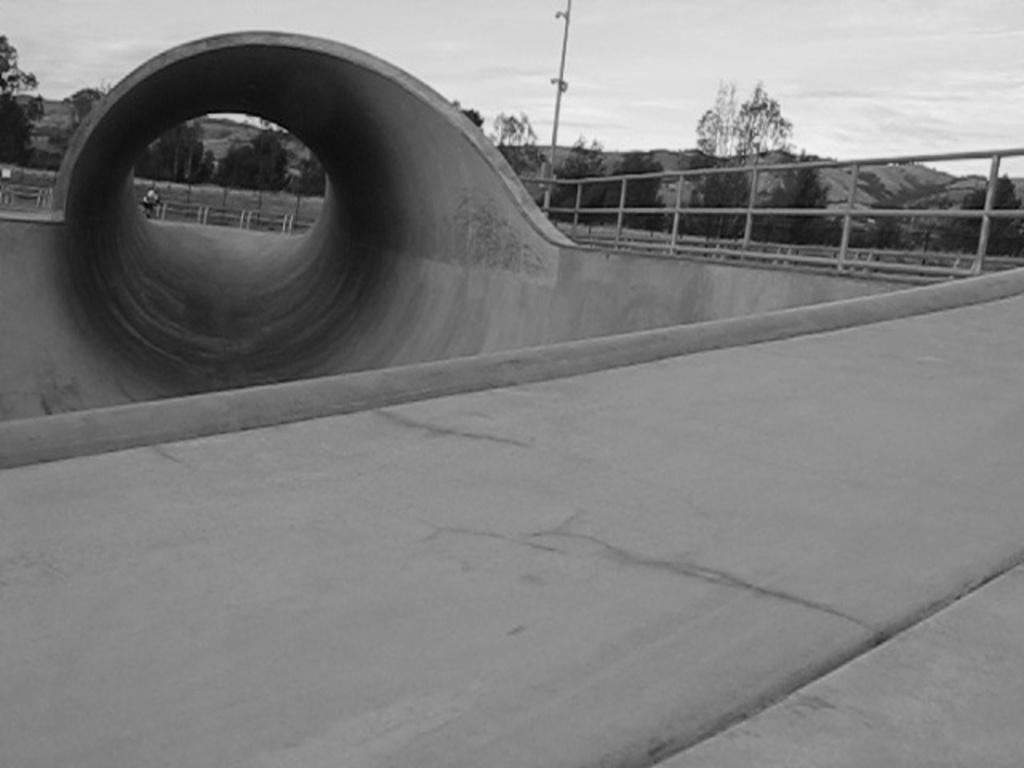What is the color scheme of the image? The image is black and white. What type of structure can be seen in the image? There is a bridge in the image. What other feature is present in the top left of the image? There is a tunnel in the top left of the image. What type of vegetation is visible in the image? There are trees visible in the image. What is visible at the top of the image? The sky is visible at the top of the image. How many grapes are hanging from the bridge in the image? There are no grapes present in the image, as it features a black and white scene with a bridge, tunnel, trees, and sky. 